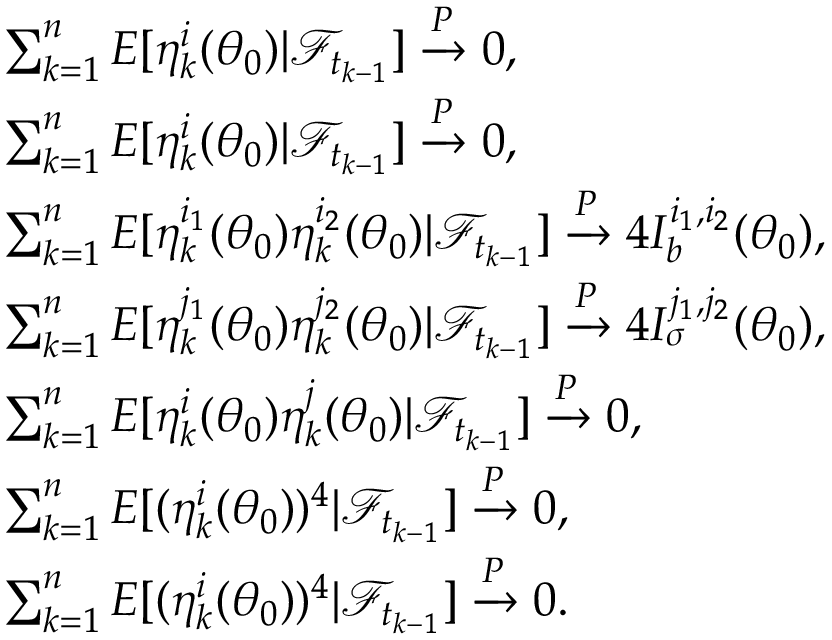<formula> <loc_0><loc_0><loc_500><loc_500>\begin{array} { r l } & { \sum _ { k = 1 } ^ { n } E [ \eta _ { k } ^ { i } ( \theta _ { 0 } ) | \mathcal { F } _ { t _ { k - 1 } } ] \xrightarrow { P } 0 , } \\ & { \sum _ { k = 1 } ^ { n } E [ \eta _ { k } ^ { i } ( \theta _ { 0 } ) | \mathcal { F } _ { t _ { k - 1 } } ] \xrightarrow { P } 0 , } \\ & { \sum _ { k = 1 } ^ { n } E [ \eta _ { k } ^ { i _ { 1 } } ( \theta _ { 0 } ) \eta _ { k } ^ { i _ { 2 } } ( \theta _ { 0 } ) | \mathcal { F } _ { t _ { k - 1 } } ] \xrightarrow { P } 4 I _ { b } ^ { i _ { 1 } , i _ { 2 } } ( \theta _ { 0 } ) , } \\ & { \sum _ { k = 1 } ^ { n } E [ \eta _ { k } ^ { j _ { 1 } } ( \theta _ { 0 } ) \eta _ { k } ^ { j _ { 2 } } ( \theta _ { 0 } ) | \mathcal { F } _ { t _ { k - 1 } } ] \xrightarrow { P } 4 I _ { \sigma } ^ { j _ { 1 } , j _ { 2 } } ( \theta _ { 0 } ) , } \\ & { \sum _ { k = 1 } ^ { n } E [ \eta _ { k } ^ { i } ( \theta _ { 0 } ) \eta _ { k } ^ { j } ( \theta _ { 0 } ) | \mathcal { F } _ { t _ { k - 1 } } ] \xrightarrow { P } 0 , } \\ & { \sum _ { k = 1 } ^ { n } E [ ( \eta _ { k } ^ { i } ( \theta _ { 0 } ) ) ^ { 4 } | \mathcal { F } _ { t _ { k - 1 } } ] \xrightarrow { P } 0 , } \\ & { \sum _ { k = 1 } ^ { n } E [ ( \eta _ { k } ^ { i } ( \theta _ { 0 } ) ) ^ { 4 } | \mathcal { F } _ { t _ { k - 1 } } ] \xrightarrow { P } 0 . } \end{array}</formula> 